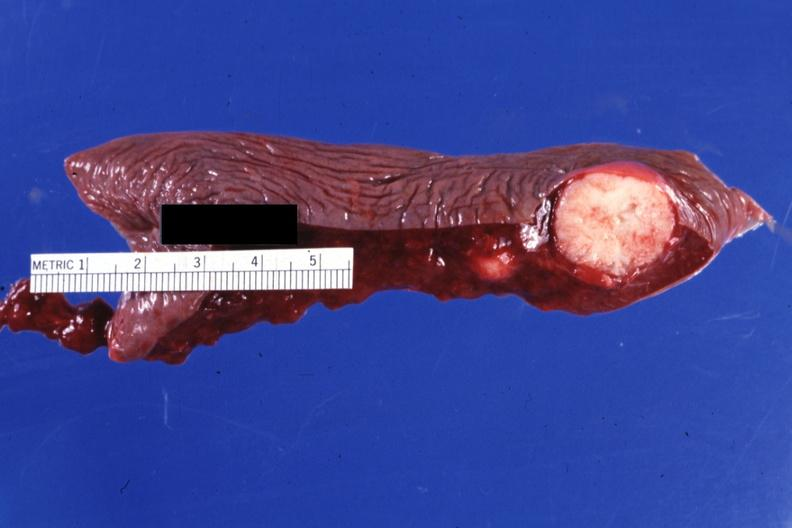does dysplastic show cut surface typical?
Answer the question using a single word or phrase. No 